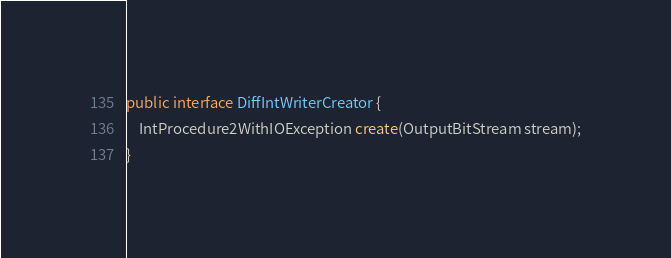<code> <loc_0><loc_0><loc_500><loc_500><_Java_>
public interface DiffIntWriterCreator {
    IntProcedure2WithIOException create(OutputBitStream stream);
}
</code> 